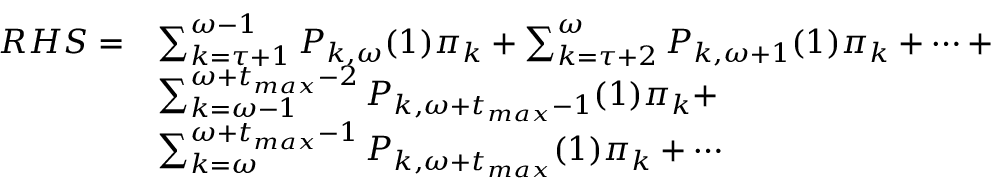Convert formula to latex. <formula><loc_0><loc_0><loc_500><loc_500>\begin{array} { r l } { R H S = } & { \sum _ { k = \tau + 1 } ^ { \omega - 1 } P _ { k , \omega } ( 1 ) \pi _ { k } + \sum _ { k = \tau + 2 } ^ { \omega } P _ { k , \omega + 1 } ( 1 ) \pi _ { k } + \cdots + } \\ & { \sum _ { k = \omega - 1 } ^ { \omega + t _ { \max } - 2 } P _ { k , \omega + t _ { \max } - 1 } ( 1 ) \pi _ { k } + } \\ & { \sum _ { k = \omega } ^ { \omega + t _ { \max } - 1 } P _ { k , \omega + t _ { \max } } ( 1 ) \pi _ { k } + \cdots } \end{array}</formula> 